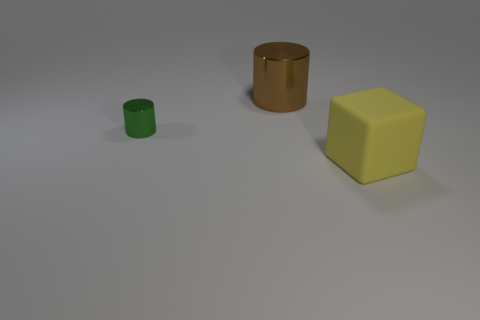There is a object on the right side of the brown cylinder; how big is it?
Your answer should be very brief. Large. Is there anything else that has the same color as the big block?
Ensure brevity in your answer.  No. There is a large object behind the thing on the left side of the brown thing; what color is it?
Provide a succinct answer. Brown. What number of large objects are either shiny things or rubber things?
Your answer should be very brief. 2. Is there any other thing that has the same material as the big yellow block?
Ensure brevity in your answer.  No. The small metal thing has what color?
Your answer should be very brief. Green. What number of shiny cylinders are in front of the large thing left of the large rubber block?
Your answer should be very brief. 1. What size is the object that is both right of the tiny metal object and in front of the big brown metallic thing?
Your response must be concise. Large. There is a big thing behind the big cube; what is it made of?
Make the answer very short. Metal. Is there another tiny shiny object of the same shape as the brown metal thing?
Your answer should be compact. Yes. 